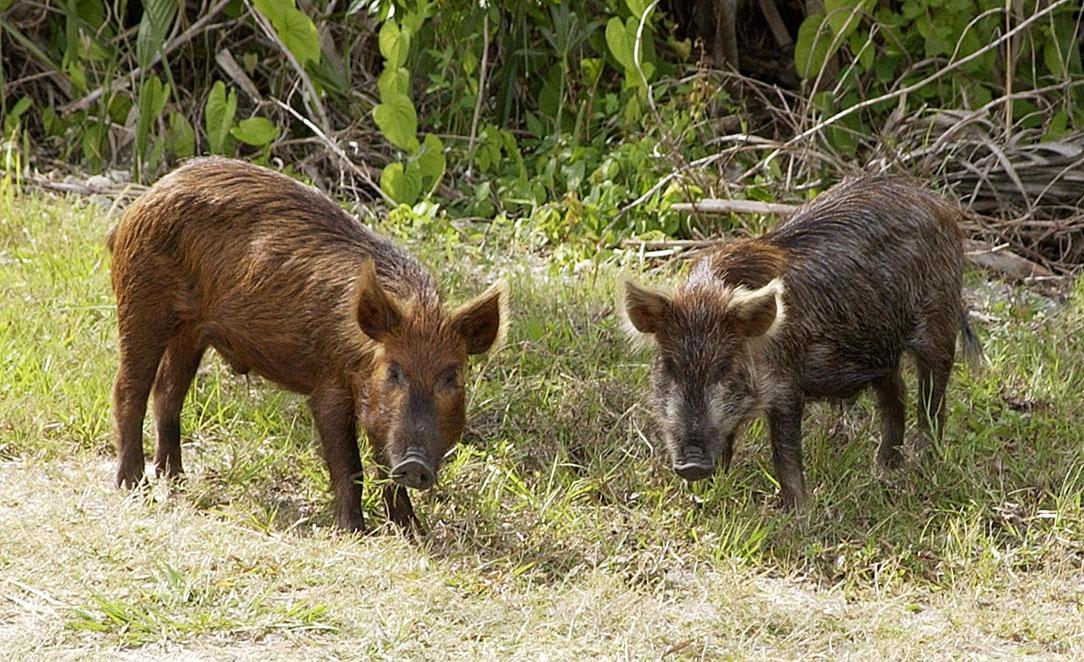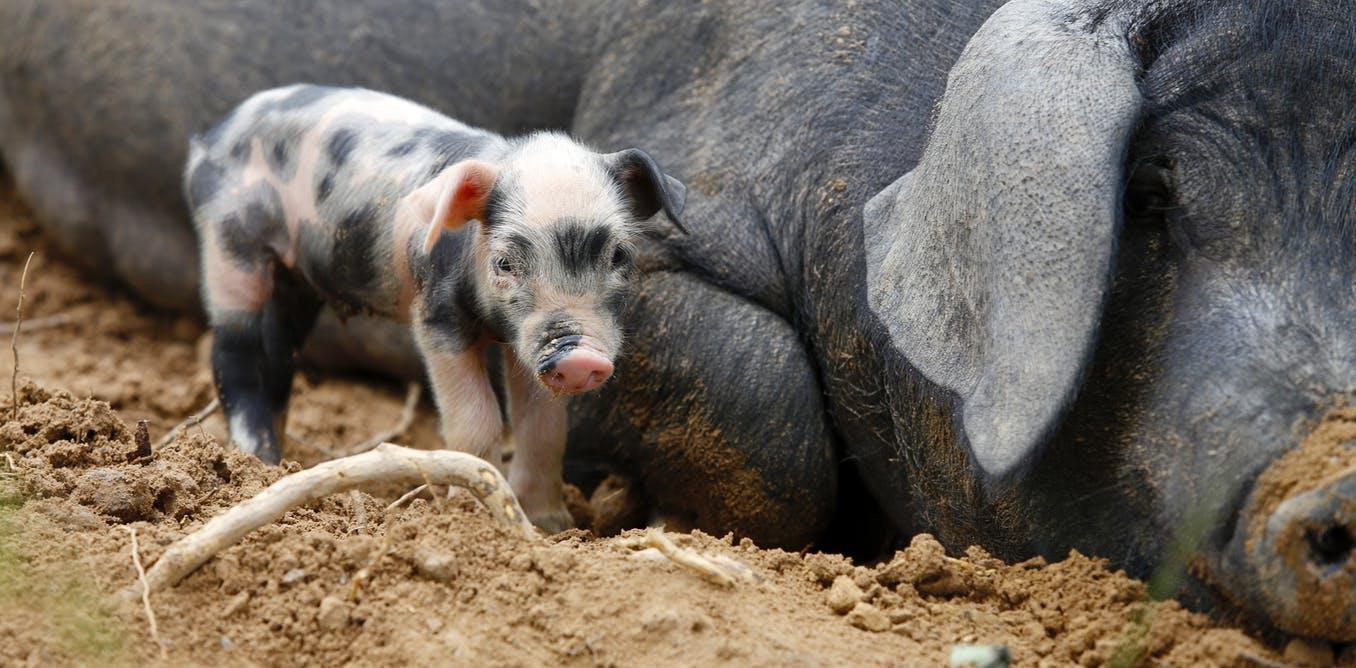The first image is the image on the left, the second image is the image on the right. Given the left and right images, does the statement "There are exactly two boars, and they don't look like the same boar." hold true? Answer yes or no. No. 